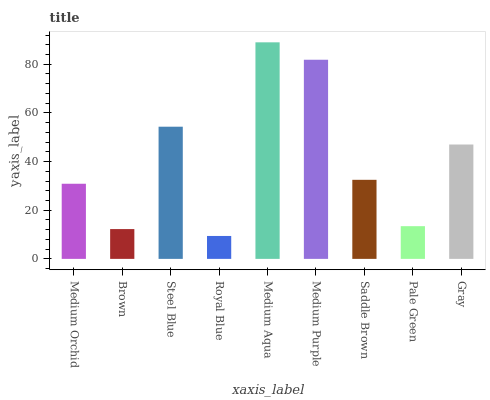Is Royal Blue the minimum?
Answer yes or no. Yes. Is Medium Aqua the maximum?
Answer yes or no. Yes. Is Brown the minimum?
Answer yes or no. No. Is Brown the maximum?
Answer yes or no. No. Is Medium Orchid greater than Brown?
Answer yes or no. Yes. Is Brown less than Medium Orchid?
Answer yes or no. Yes. Is Brown greater than Medium Orchid?
Answer yes or no. No. Is Medium Orchid less than Brown?
Answer yes or no. No. Is Saddle Brown the high median?
Answer yes or no. Yes. Is Saddle Brown the low median?
Answer yes or no. Yes. Is Steel Blue the high median?
Answer yes or no. No. Is Brown the low median?
Answer yes or no. No. 